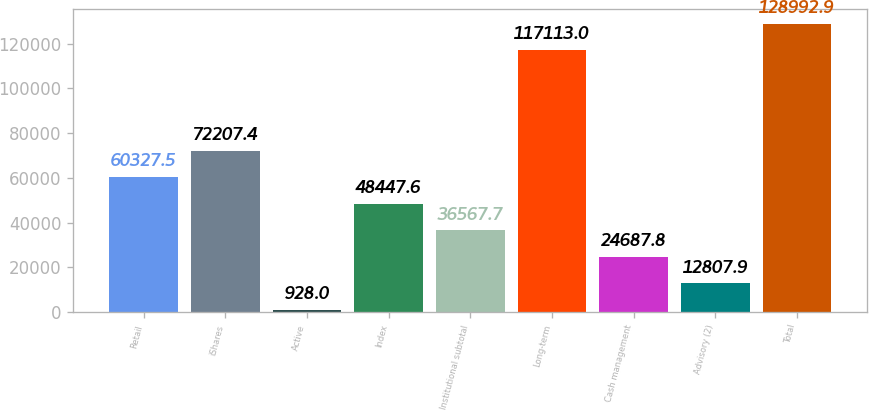Convert chart. <chart><loc_0><loc_0><loc_500><loc_500><bar_chart><fcel>Retail<fcel>iShares<fcel>Active<fcel>Index<fcel>Institutional subtotal<fcel>Long-term<fcel>Cash management<fcel>Advisory (2)<fcel>Total<nl><fcel>60327.5<fcel>72207.4<fcel>928<fcel>48447.6<fcel>36567.7<fcel>117113<fcel>24687.8<fcel>12807.9<fcel>128993<nl></chart> 